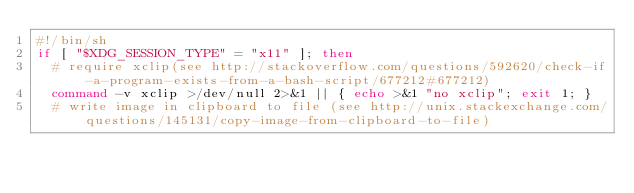<code> <loc_0><loc_0><loc_500><loc_500><_Bash_>#!/bin/sh
if [ "$XDG_SESSION_TYPE" = "x11" ]; then
  # require xclip(see http://stackoverflow.com/questions/592620/check-if-a-program-exists-from-a-bash-script/677212#677212)
  command -v xclip >/dev/null 2>&1 || { echo >&1 "no xclip"; exit 1; }
  # write image in clipboard to file (see http://unix.stackexchange.com/questions/145131/copy-image-from-clipboard-to-file)</code> 